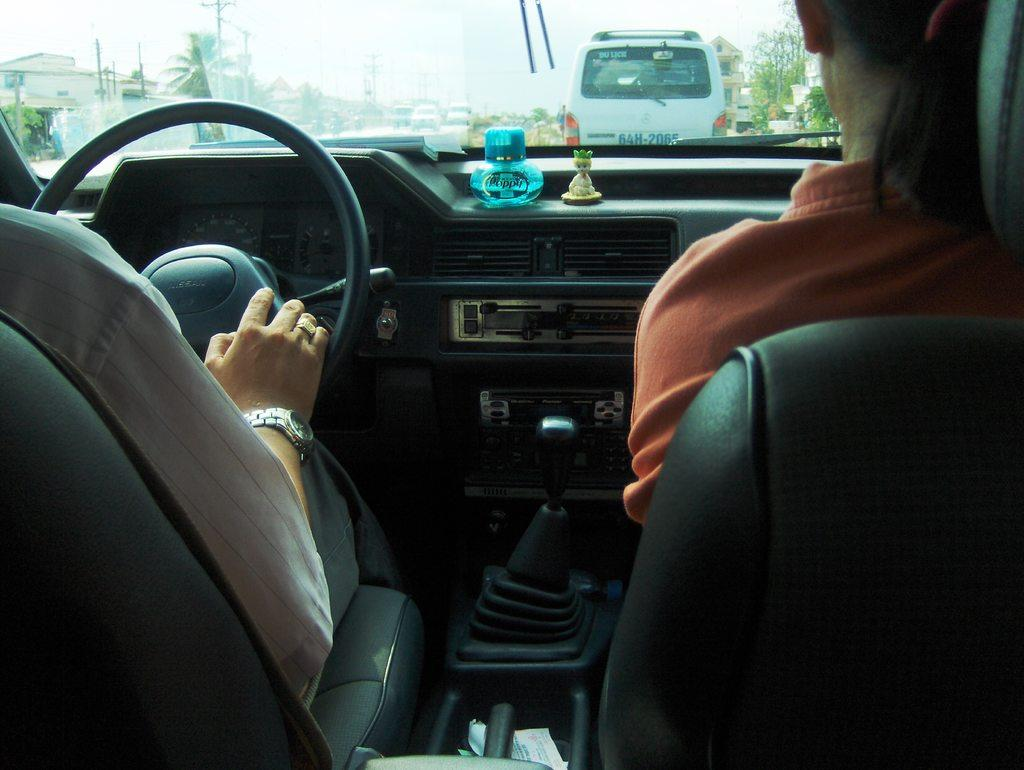How many people are inside the vehicle in the image? There are two persons inside the vehicle. What objects can be seen inside the vehicle? There is a bottle and a toy visible inside the vehicle. What can be seen through the glass (window) of the vehicle? Vehicles, trees, poles, buildings, and the sky can be seen through the glass. What type of teeth can be seen inside the vehicle? There are no teeth visible inside the vehicle; it contains two persons, a bottle, and a toy. What title is displayed on the vehicle? The provided facts do not mention any title being displayed on the vehicle. 